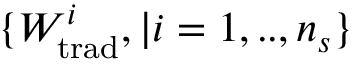<formula> <loc_0><loc_0><loc_500><loc_500>\{ W _ { t r a d } ^ { i } , | i = 1 , . . , n _ { s } \}</formula> 